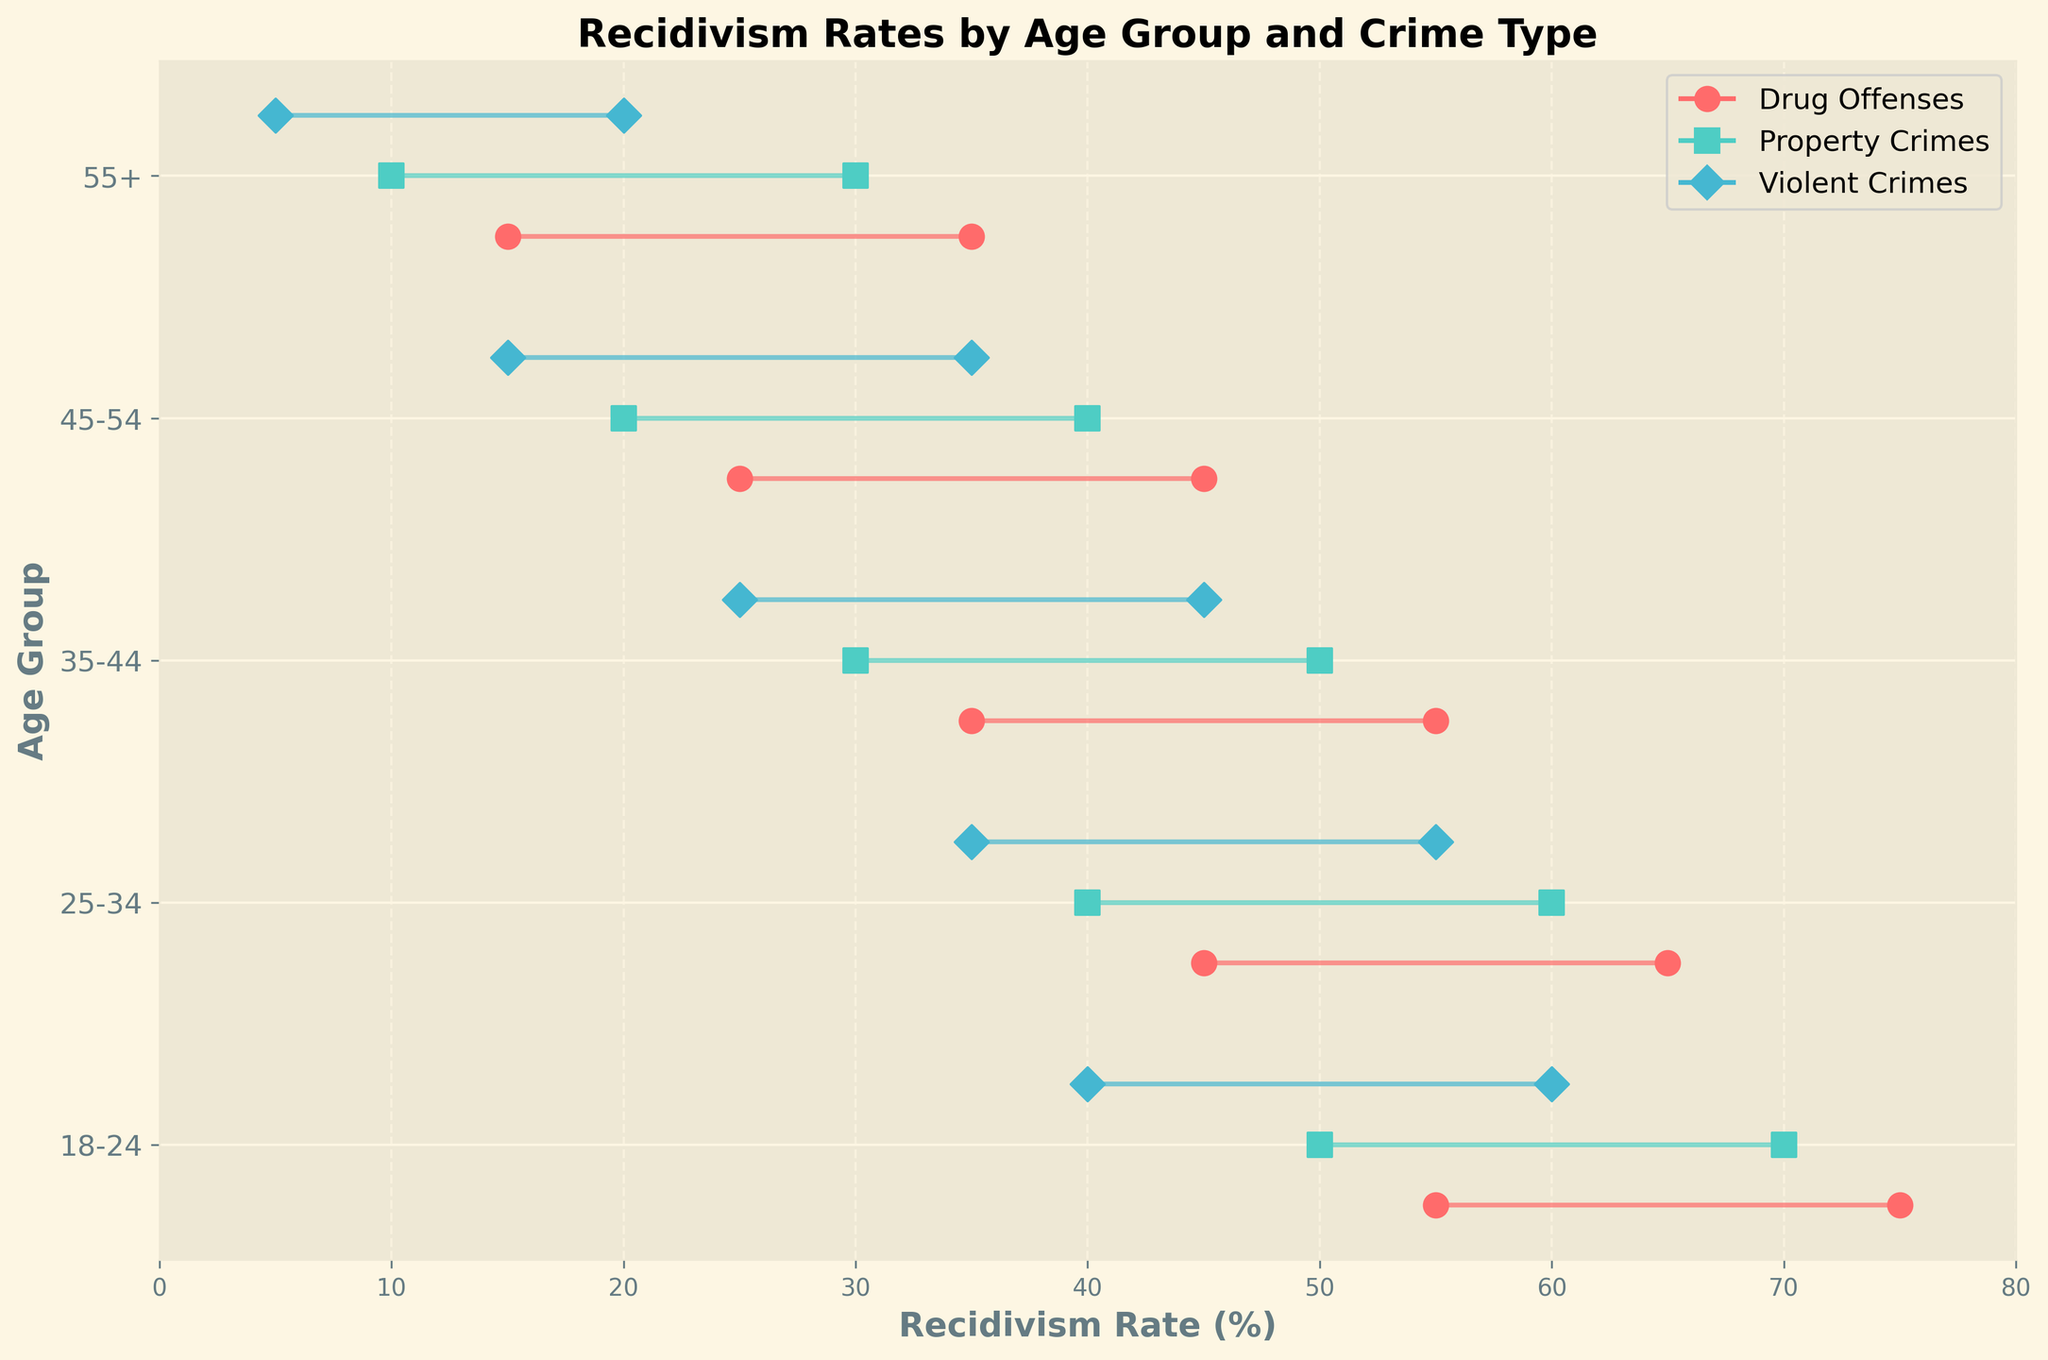What's the title of the figure? The title is displayed at the top of the figure in bold text. It summarizes what the plot is about.
Answer: Recidivism Rates by Age Group and Crime Type What is the range of recidivism rates for Property Crimes in the 35-44 age group? The lower and upper bounds for recidivism rates are shown as dots connected by a line. For Property Crimes in the 35-44 age group, the lower bound is 30% and the upper bound is 50%.
Answer: 30% to 50% Which age group shows the highest upper limit of recidivism rate for Drug Offenses? Compare the upper limit rates for Drug Offenses across different age groups. The 18-24 age group has the highest upper limit at 75%.
Answer: 18-24 Among the 25-34 age group, which type of crime has the lowest lower limit of recidivism rate? Identify the lower limits for all crime types within the 25-34 age group. Violent Crimes have the lowest lower limit at 35%.
Answer: Violent Crimes How does the range of recidivism rates for Violent Crimes compare between the 18-24 and 55+ age groups? Look at the range (difference between upper and lower limits) for Violent Crimes in both age groups. For 18-24, the range is from 40% to 60% (20%), and for 55+, it is from 5% to 20% (15%).
Answer: The range for the 18-24 group is larger What's the difference in the upper limits of recidivism rates for Property Crimes between the 18-24 and 45-54 age groups? Subtract the upper limit for the 45-54 age group (40%) from that of the 18-24 age group (70%).
Answer: 30% Which age group has the smallest range of recidivism rates for Drug Offenses? Calculate the ranges for Drug Offenses across the age groups. The smallest range is found for the 55+ age group, which is from 15% to 35% (20%).
Answer: 55+ Are there any age groups where the recidivism rate for Violent Crimes does not overlap with the rate for any other crime type? Examine each age group’s ranges for Violent Crimes and compare them to the ranges for other crime types. For the 55+ age group, the upper limit for Violent Crimes (20%) is lower than the lower limit for Property Crimes (30%).
Answer: 55+ How does the recidivism rate range for Property Crimes in the 25-34 age group compare to that in the 35-44 age group? Compare both the lower and upper limits of recidivism rates for Property Crimes in both age groups. The 25-34 age group has a range from 40% to 60%, while the 35-44 age group has a range from 30% to 50%.
Answer: The 25-34 age group has higher overall rates 